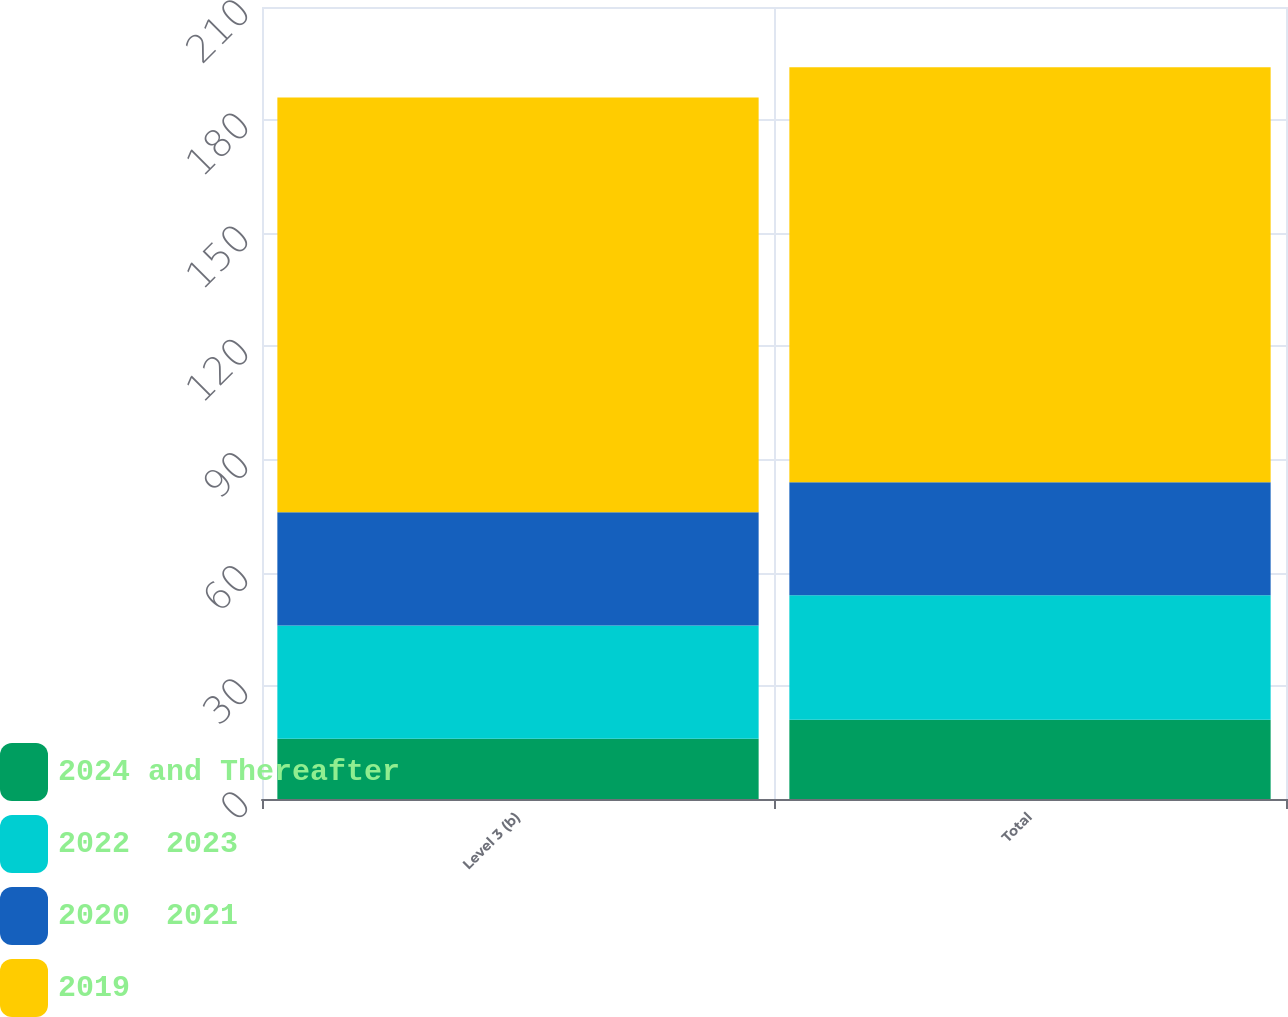<chart> <loc_0><loc_0><loc_500><loc_500><stacked_bar_chart><ecel><fcel>Level 3 (b)<fcel>Total<nl><fcel>2024 and Thereafter<fcel>16<fcel>21<nl><fcel>2022  2023<fcel>30<fcel>33<nl><fcel>2020  2021<fcel>30<fcel>30<nl><fcel>2019<fcel>110<fcel>110<nl></chart> 